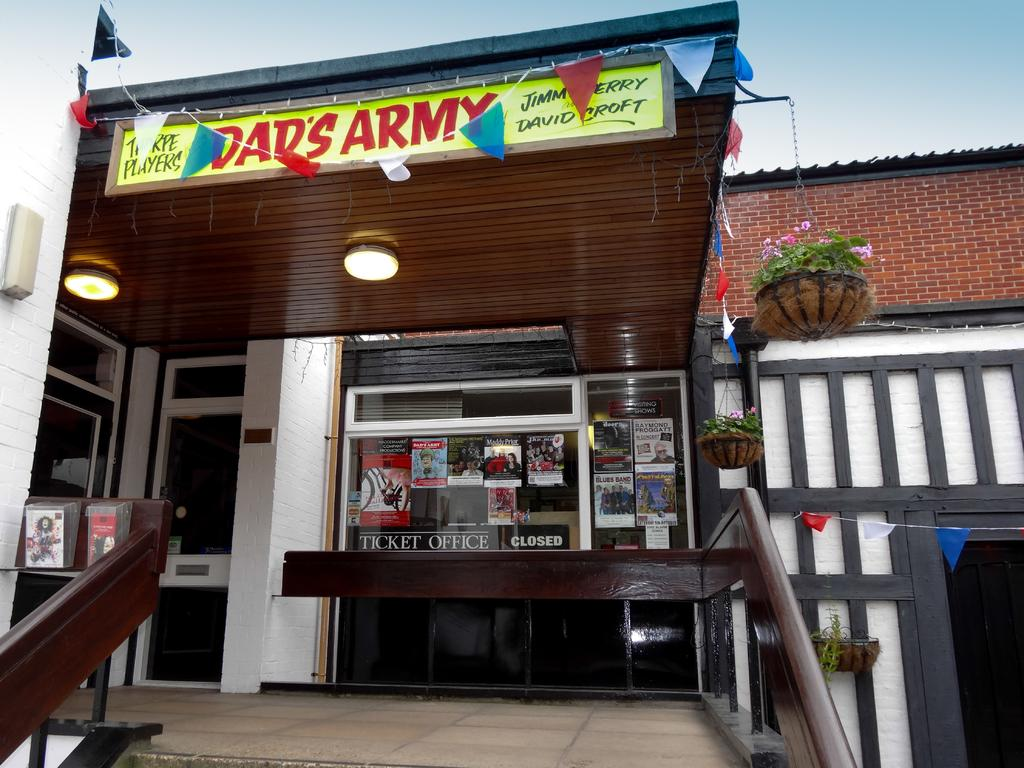<image>
Create a compact narrative representing the image presented. Dad's Army store is open but the ticket office is closed. 